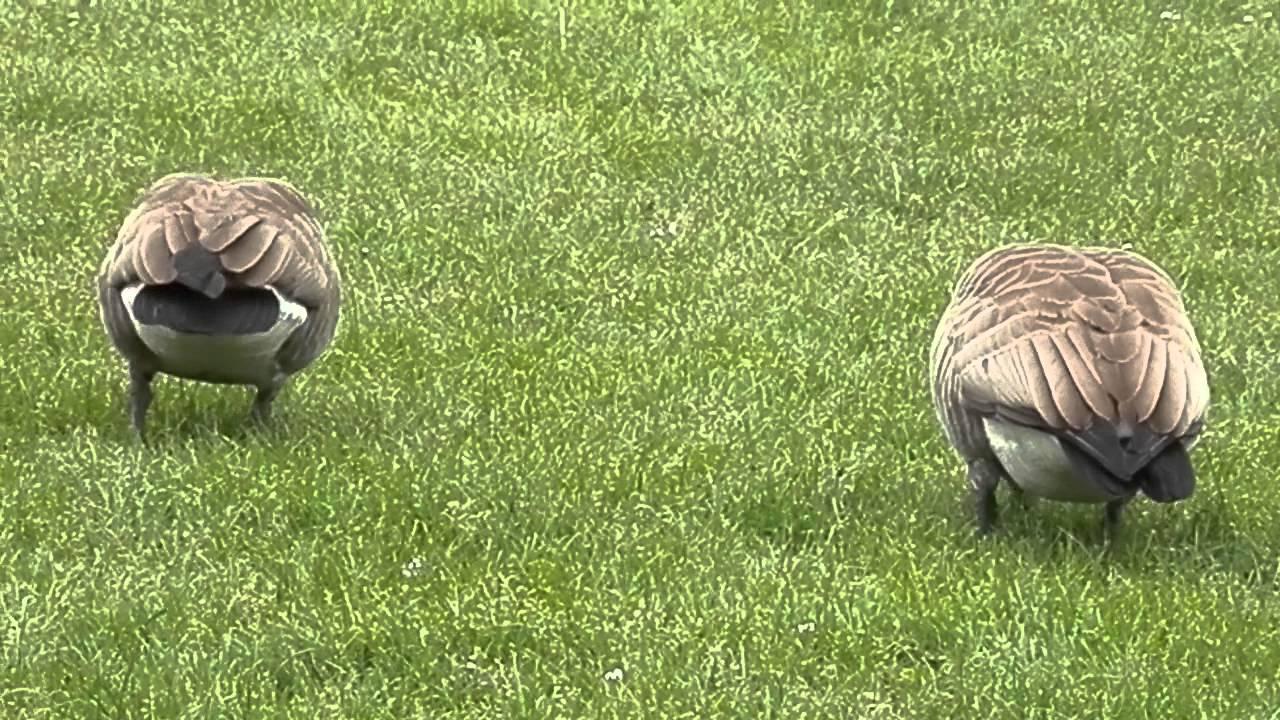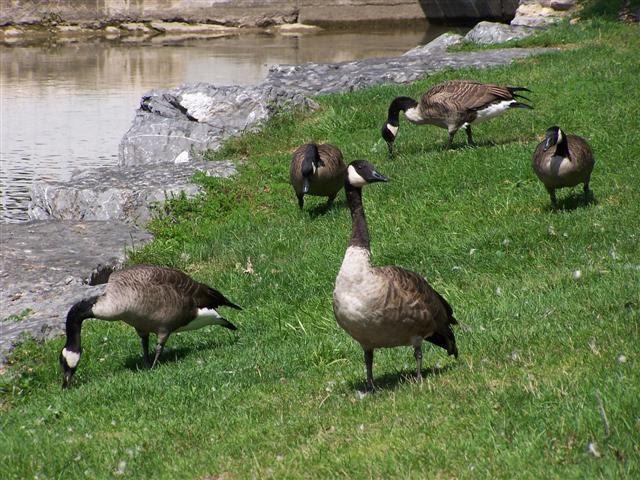The first image is the image on the left, the second image is the image on the right. Considering the images on both sides, is "There are no more than four birds." valid? Answer yes or no. No. The first image is the image on the left, the second image is the image on the right. For the images shown, is this caption "There is an image of a single goose that has its head bent to the ground." true? Answer yes or no. No. 